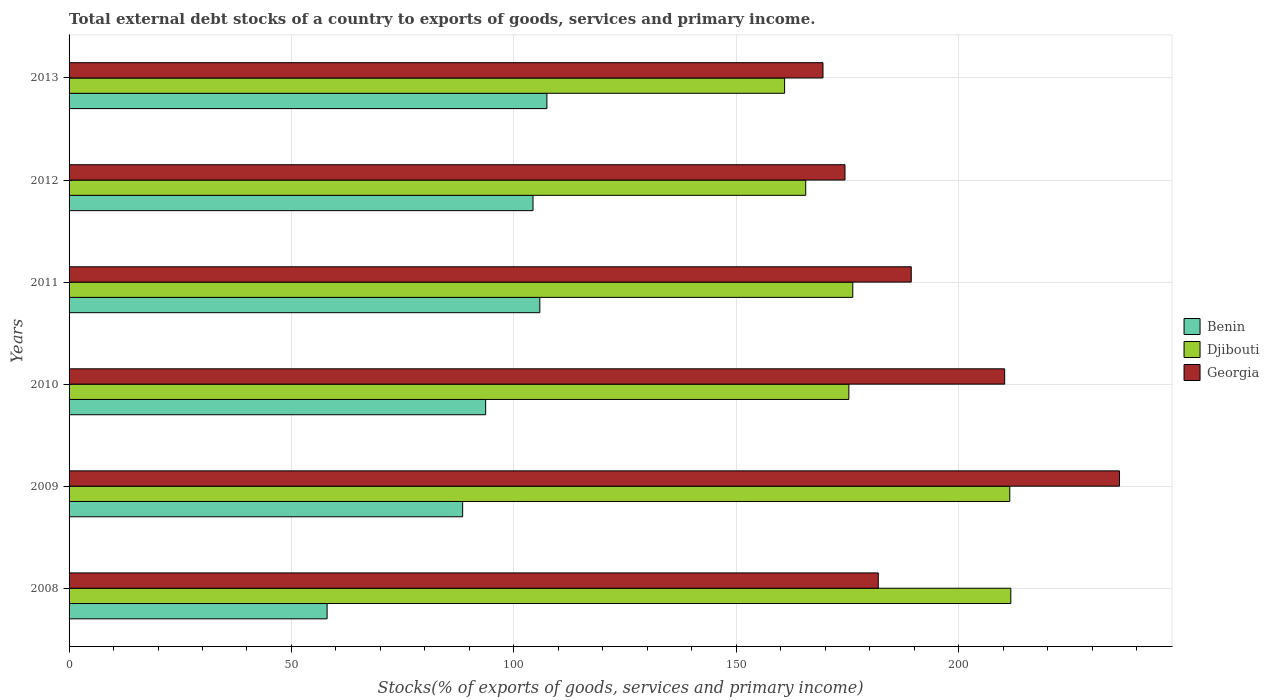Are the number of bars per tick equal to the number of legend labels?
Offer a terse response. Yes. Are the number of bars on each tick of the Y-axis equal?
Offer a very short reply. Yes. How many bars are there on the 3rd tick from the bottom?
Make the answer very short. 3. What is the label of the 6th group of bars from the top?
Your answer should be very brief. 2008. What is the total debt stocks in Benin in 2008?
Your response must be concise. 58.01. Across all years, what is the maximum total debt stocks in Benin?
Offer a very short reply. 107.43. Across all years, what is the minimum total debt stocks in Djibouti?
Keep it short and to the point. 160.87. In which year was the total debt stocks in Benin maximum?
Offer a terse response. 2013. In which year was the total debt stocks in Georgia minimum?
Provide a succinct answer. 2013. What is the total total debt stocks in Djibouti in the graph?
Offer a terse response. 1101.24. What is the difference between the total debt stocks in Benin in 2011 and that in 2012?
Your answer should be compact. 1.53. What is the difference between the total debt stocks in Georgia in 2010 and the total debt stocks in Benin in 2009?
Provide a short and direct response. 121.87. What is the average total debt stocks in Georgia per year?
Your answer should be very brief. 193.62. In the year 2008, what is the difference between the total debt stocks in Georgia and total debt stocks in Djibouti?
Offer a terse response. -29.8. In how many years, is the total debt stocks in Benin greater than 90 %?
Offer a very short reply. 4. What is the ratio of the total debt stocks in Djibouti in 2008 to that in 2011?
Offer a terse response. 1.2. Is the difference between the total debt stocks in Georgia in 2010 and 2011 greater than the difference between the total debt stocks in Djibouti in 2010 and 2011?
Offer a terse response. Yes. What is the difference between the highest and the second highest total debt stocks in Benin?
Keep it short and to the point. 1.59. What is the difference between the highest and the lowest total debt stocks in Djibouti?
Provide a short and direct response. 50.86. What does the 1st bar from the top in 2008 represents?
Your answer should be compact. Georgia. What does the 3rd bar from the bottom in 2009 represents?
Provide a succinct answer. Georgia. Is it the case that in every year, the sum of the total debt stocks in Benin and total debt stocks in Djibouti is greater than the total debt stocks in Georgia?
Keep it short and to the point. Yes. Are all the bars in the graph horizontal?
Keep it short and to the point. Yes. How many years are there in the graph?
Your answer should be compact. 6. Are the values on the major ticks of X-axis written in scientific E-notation?
Your answer should be compact. No. Does the graph contain any zero values?
Offer a very short reply. No. Does the graph contain grids?
Keep it short and to the point. Yes. What is the title of the graph?
Provide a short and direct response. Total external debt stocks of a country to exports of goods, services and primary income. Does "Bahamas" appear as one of the legend labels in the graph?
Your response must be concise. No. What is the label or title of the X-axis?
Give a very brief answer. Stocks(% of exports of goods, services and primary income). What is the label or title of the Y-axis?
Offer a terse response. Years. What is the Stocks(% of exports of goods, services and primary income) in Benin in 2008?
Provide a succinct answer. 58.01. What is the Stocks(% of exports of goods, services and primary income) of Djibouti in 2008?
Give a very brief answer. 211.73. What is the Stocks(% of exports of goods, services and primary income) in Georgia in 2008?
Your answer should be very brief. 181.93. What is the Stocks(% of exports of goods, services and primary income) in Benin in 2009?
Offer a terse response. 88.48. What is the Stocks(% of exports of goods, services and primary income) in Djibouti in 2009?
Your answer should be compact. 211.5. What is the Stocks(% of exports of goods, services and primary income) in Georgia in 2009?
Offer a terse response. 236.17. What is the Stocks(% of exports of goods, services and primary income) of Benin in 2010?
Offer a terse response. 93.66. What is the Stocks(% of exports of goods, services and primary income) of Djibouti in 2010?
Give a very brief answer. 175.32. What is the Stocks(% of exports of goods, services and primary income) of Georgia in 2010?
Keep it short and to the point. 210.35. What is the Stocks(% of exports of goods, services and primary income) in Benin in 2011?
Ensure brevity in your answer.  105.84. What is the Stocks(% of exports of goods, services and primary income) of Djibouti in 2011?
Provide a succinct answer. 176.2. What is the Stocks(% of exports of goods, services and primary income) in Georgia in 2011?
Make the answer very short. 189.34. What is the Stocks(% of exports of goods, services and primary income) of Benin in 2012?
Make the answer very short. 104.31. What is the Stocks(% of exports of goods, services and primary income) of Djibouti in 2012?
Keep it short and to the point. 165.62. What is the Stocks(% of exports of goods, services and primary income) of Georgia in 2012?
Your answer should be compact. 174.45. What is the Stocks(% of exports of goods, services and primary income) in Benin in 2013?
Your response must be concise. 107.43. What is the Stocks(% of exports of goods, services and primary income) in Djibouti in 2013?
Ensure brevity in your answer.  160.87. What is the Stocks(% of exports of goods, services and primary income) of Georgia in 2013?
Offer a terse response. 169.5. Across all years, what is the maximum Stocks(% of exports of goods, services and primary income) of Benin?
Make the answer very short. 107.43. Across all years, what is the maximum Stocks(% of exports of goods, services and primary income) of Djibouti?
Make the answer very short. 211.73. Across all years, what is the maximum Stocks(% of exports of goods, services and primary income) of Georgia?
Your answer should be compact. 236.17. Across all years, what is the minimum Stocks(% of exports of goods, services and primary income) of Benin?
Make the answer very short. 58.01. Across all years, what is the minimum Stocks(% of exports of goods, services and primary income) of Djibouti?
Give a very brief answer. 160.87. Across all years, what is the minimum Stocks(% of exports of goods, services and primary income) of Georgia?
Give a very brief answer. 169.5. What is the total Stocks(% of exports of goods, services and primary income) in Benin in the graph?
Give a very brief answer. 557.74. What is the total Stocks(% of exports of goods, services and primary income) in Djibouti in the graph?
Your answer should be compact. 1101.24. What is the total Stocks(% of exports of goods, services and primary income) in Georgia in the graph?
Ensure brevity in your answer.  1161.74. What is the difference between the Stocks(% of exports of goods, services and primary income) of Benin in 2008 and that in 2009?
Make the answer very short. -30.47. What is the difference between the Stocks(% of exports of goods, services and primary income) of Djibouti in 2008 and that in 2009?
Your answer should be compact. 0.23. What is the difference between the Stocks(% of exports of goods, services and primary income) of Georgia in 2008 and that in 2009?
Offer a terse response. -54.24. What is the difference between the Stocks(% of exports of goods, services and primary income) of Benin in 2008 and that in 2010?
Your response must be concise. -35.65. What is the difference between the Stocks(% of exports of goods, services and primary income) in Djibouti in 2008 and that in 2010?
Offer a very short reply. 36.41. What is the difference between the Stocks(% of exports of goods, services and primary income) in Georgia in 2008 and that in 2010?
Offer a terse response. -28.42. What is the difference between the Stocks(% of exports of goods, services and primary income) in Benin in 2008 and that in 2011?
Provide a succinct answer. -47.82. What is the difference between the Stocks(% of exports of goods, services and primary income) of Djibouti in 2008 and that in 2011?
Offer a very short reply. 35.53. What is the difference between the Stocks(% of exports of goods, services and primary income) in Georgia in 2008 and that in 2011?
Offer a very short reply. -7.41. What is the difference between the Stocks(% of exports of goods, services and primary income) in Benin in 2008 and that in 2012?
Your answer should be very brief. -46.29. What is the difference between the Stocks(% of exports of goods, services and primary income) in Djibouti in 2008 and that in 2012?
Provide a succinct answer. 46.11. What is the difference between the Stocks(% of exports of goods, services and primary income) in Georgia in 2008 and that in 2012?
Make the answer very short. 7.48. What is the difference between the Stocks(% of exports of goods, services and primary income) of Benin in 2008 and that in 2013?
Ensure brevity in your answer.  -49.42. What is the difference between the Stocks(% of exports of goods, services and primary income) in Djibouti in 2008 and that in 2013?
Your response must be concise. 50.86. What is the difference between the Stocks(% of exports of goods, services and primary income) of Georgia in 2008 and that in 2013?
Ensure brevity in your answer.  12.43. What is the difference between the Stocks(% of exports of goods, services and primary income) of Benin in 2009 and that in 2010?
Offer a terse response. -5.18. What is the difference between the Stocks(% of exports of goods, services and primary income) in Djibouti in 2009 and that in 2010?
Ensure brevity in your answer.  36.18. What is the difference between the Stocks(% of exports of goods, services and primary income) of Georgia in 2009 and that in 2010?
Make the answer very short. 25.82. What is the difference between the Stocks(% of exports of goods, services and primary income) of Benin in 2009 and that in 2011?
Offer a very short reply. -17.35. What is the difference between the Stocks(% of exports of goods, services and primary income) of Djibouti in 2009 and that in 2011?
Offer a terse response. 35.3. What is the difference between the Stocks(% of exports of goods, services and primary income) of Georgia in 2009 and that in 2011?
Offer a terse response. 46.83. What is the difference between the Stocks(% of exports of goods, services and primary income) in Benin in 2009 and that in 2012?
Keep it short and to the point. -15.82. What is the difference between the Stocks(% of exports of goods, services and primary income) in Djibouti in 2009 and that in 2012?
Your answer should be very brief. 45.88. What is the difference between the Stocks(% of exports of goods, services and primary income) in Georgia in 2009 and that in 2012?
Give a very brief answer. 61.72. What is the difference between the Stocks(% of exports of goods, services and primary income) in Benin in 2009 and that in 2013?
Offer a terse response. -18.95. What is the difference between the Stocks(% of exports of goods, services and primary income) of Djibouti in 2009 and that in 2013?
Provide a short and direct response. 50.62. What is the difference between the Stocks(% of exports of goods, services and primary income) in Georgia in 2009 and that in 2013?
Give a very brief answer. 66.67. What is the difference between the Stocks(% of exports of goods, services and primary income) in Benin in 2010 and that in 2011?
Provide a short and direct response. -12.18. What is the difference between the Stocks(% of exports of goods, services and primary income) of Djibouti in 2010 and that in 2011?
Your answer should be compact. -0.88. What is the difference between the Stocks(% of exports of goods, services and primary income) of Georgia in 2010 and that in 2011?
Your response must be concise. 21.01. What is the difference between the Stocks(% of exports of goods, services and primary income) of Benin in 2010 and that in 2012?
Ensure brevity in your answer.  -10.65. What is the difference between the Stocks(% of exports of goods, services and primary income) of Djibouti in 2010 and that in 2012?
Provide a succinct answer. 9.7. What is the difference between the Stocks(% of exports of goods, services and primary income) in Georgia in 2010 and that in 2012?
Your answer should be compact. 35.9. What is the difference between the Stocks(% of exports of goods, services and primary income) of Benin in 2010 and that in 2013?
Offer a terse response. -13.77. What is the difference between the Stocks(% of exports of goods, services and primary income) in Djibouti in 2010 and that in 2013?
Make the answer very short. 14.44. What is the difference between the Stocks(% of exports of goods, services and primary income) in Georgia in 2010 and that in 2013?
Your answer should be compact. 40.85. What is the difference between the Stocks(% of exports of goods, services and primary income) in Benin in 2011 and that in 2012?
Give a very brief answer. 1.53. What is the difference between the Stocks(% of exports of goods, services and primary income) of Djibouti in 2011 and that in 2012?
Give a very brief answer. 10.58. What is the difference between the Stocks(% of exports of goods, services and primary income) in Georgia in 2011 and that in 2012?
Your answer should be compact. 14.89. What is the difference between the Stocks(% of exports of goods, services and primary income) of Benin in 2011 and that in 2013?
Your answer should be compact. -1.59. What is the difference between the Stocks(% of exports of goods, services and primary income) of Djibouti in 2011 and that in 2013?
Provide a short and direct response. 15.32. What is the difference between the Stocks(% of exports of goods, services and primary income) of Georgia in 2011 and that in 2013?
Provide a short and direct response. 19.84. What is the difference between the Stocks(% of exports of goods, services and primary income) in Benin in 2012 and that in 2013?
Your answer should be compact. -3.12. What is the difference between the Stocks(% of exports of goods, services and primary income) in Djibouti in 2012 and that in 2013?
Your answer should be compact. 4.75. What is the difference between the Stocks(% of exports of goods, services and primary income) of Georgia in 2012 and that in 2013?
Keep it short and to the point. 4.95. What is the difference between the Stocks(% of exports of goods, services and primary income) of Benin in 2008 and the Stocks(% of exports of goods, services and primary income) of Djibouti in 2009?
Ensure brevity in your answer.  -153.48. What is the difference between the Stocks(% of exports of goods, services and primary income) in Benin in 2008 and the Stocks(% of exports of goods, services and primary income) in Georgia in 2009?
Your response must be concise. -178.15. What is the difference between the Stocks(% of exports of goods, services and primary income) of Djibouti in 2008 and the Stocks(% of exports of goods, services and primary income) of Georgia in 2009?
Ensure brevity in your answer.  -24.44. What is the difference between the Stocks(% of exports of goods, services and primary income) of Benin in 2008 and the Stocks(% of exports of goods, services and primary income) of Djibouti in 2010?
Your response must be concise. -117.3. What is the difference between the Stocks(% of exports of goods, services and primary income) in Benin in 2008 and the Stocks(% of exports of goods, services and primary income) in Georgia in 2010?
Your response must be concise. -152.33. What is the difference between the Stocks(% of exports of goods, services and primary income) of Djibouti in 2008 and the Stocks(% of exports of goods, services and primary income) of Georgia in 2010?
Offer a very short reply. 1.38. What is the difference between the Stocks(% of exports of goods, services and primary income) in Benin in 2008 and the Stocks(% of exports of goods, services and primary income) in Djibouti in 2011?
Make the answer very short. -118.18. What is the difference between the Stocks(% of exports of goods, services and primary income) of Benin in 2008 and the Stocks(% of exports of goods, services and primary income) of Georgia in 2011?
Make the answer very short. -131.33. What is the difference between the Stocks(% of exports of goods, services and primary income) of Djibouti in 2008 and the Stocks(% of exports of goods, services and primary income) of Georgia in 2011?
Provide a short and direct response. 22.39. What is the difference between the Stocks(% of exports of goods, services and primary income) in Benin in 2008 and the Stocks(% of exports of goods, services and primary income) in Djibouti in 2012?
Make the answer very short. -107.6. What is the difference between the Stocks(% of exports of goods, services and primary income) of Benin in 2008 and the Stocks(% of exports of goods, services and primary income) of Georgia in 2012?
Your response must be concise. -116.44. What is the difference between the Stocks(% of exports of goods, services and primary income) of Djibouti in 2008 and the Stocks(% of exports of goods, services and primary income) of Georgia in 2012?
Your response must be concise. 37.28. What is the difference between the Stocks(% of exports of goods, services and primary income) of Benin in 2008 and the Stocks(% of exports of goods, services and primary income) of Djibouti in 2013?
Your response must be concise. -102.86. What is the difference between the Stocks(% of exports of goods, services and primary income) in Benin in 2008 and the Stocks(% of exports of goods, services and primary income) in Georgia in 2013?
Offer a very short reply. -111.49. What is the difference between the Stocks(% of exports of goods, services and primary income) in Djibouti in 2008 and the Stocks(% of exports of goods, services and primary income) in Georgia in 2013?
Make the answer very short. 42.23. What is the difference between the Stocks(% of exports of goods, services and primary income) of Benin in 2009 and the Stocks(% of exports of goods, services and primary income) of Djibouti in 2010?
Make the answer very short. -86.83. What is the difference between the Stocks(% of exports of goods, services and primary income) of Benin in 2009 and the Stocks(% of exports of goods, services and primary income) of Georgia in 2010?
Offer a terse response. -121.87. What is the difference between the Stocks(% of exports of goods, services and primary income) in Djibouti in 2009 and the Stocks(% of exports of goods, services and primary income) in Georgia in 2010?
Make the answer very short. 1.15. What is the difference between the Stocks(% of exports of goods, services and primary income) of Benin in 2009 and the Stocks(% of exports of goods, services and primary income) of Djibouti in 2011?
Give a very brief answer. -87.71. What is the difference between the Stocks(% of exports of goods, services and primary income) of Benin in 2009 and the Stocks(% of exports of goods, services and primary income) of Georgia in 2011?
Your answer should be compact. -100.86. What is the difference between the Stocks(% of exports of goods, services and primary income) of Djibouti in 2009 and the Stocks(% of exports of goods, services and primary income) of Georgia in 2011?
Ensure brevity in your answer.  22.15. What is the difference between the Stocks(% of exports of goods, services and primary income) of Benin in 2009 and the Stocks(% of exports of goods, services and primary income) of Djibouti in 2012?
Provide a succinct answer. -77.14. What is the difference between the Stocks(% of exports of goods, services and primary income) of Benin in 2009 and the Stocks(% of exports of goods, services and primary income) of Georgia in 2012?
Your response must be concise. -85.97. What is the difference between the Stocks(% of exports of goods, services and primary income) in Djibouti in 2009 and the Stocks(% of exports of goods, services and primary income) in Georgia in 2012?
Provide a short and direct response. 37.05. What is the difference between the Stocks(% of exports of goods, services and primary income) of Benin in 2009 and the Stocks(% of exports of goods, services and primary income) of Djibouti in 2013?
Give a very brief answer. -72.39. What is the difference between the Stocks(% of exports of goods, services and primary income) in Benin in 2009 and the Stocks(% of exports of goods, services and primary income) in Georgia in 2013?
Your response must be concise. -81.02. What is the difference between the Stocks(% of exports of goods, services and primary income) of Djibouti in 2009 and the Stocks(% of exports of goods, services and primary income) of Georgia in 2013?
Offer a terse response. 42. What is the difference between the Stocks(% of exports of goods, services and primary income) of Benin in 2010 and the Stocks(% of exports of goods, services and primary income) of Djibouti in 2011?
Your response must be concise. -82.54. What is the difference between the Stocks(% of exports of goods, services and primary income) of Benin in 2010 and the Stocks(% of exports of goods, services and primary income) of Georgia in 2011?
Ensure brevity in your answer.  -95.68. What is the difference between the Stocks(% of exports of goods, services and primary income) of Djibouti in 2010 and the Stocks(% of exports of goods, services and primary income) of Georgia in 2011?
Make the answer very short. -14.02. What is the difference between the Stocks(% of exports of goods, services and primary income) in Benin in 2010 and the Stocks(% of exports of goods, services and primary income) in Djibouti in 2012?
Make the answer very short. -71.96. What is the difference between the Stocks(% of exports of goods, services and primary income) in Benin in 2010 and the Stocks(% of exports of goods, services and primary income) in Georgia in 2012?
Your response must be concise. -80.79. What is the difference between the Stocks(% of exports of goods, services and primary income) in Djibouti in 2010 and the Stocks(% of exports of goods, services and primary income) in Georgia in 2012?
Offer a very short reply. 0.87. What is the difference between the Stocks(% of exports of goods, services and primary income) of Benin in 2010 and the Stocks(% of exports of goods, services and primary income) of Djibouti in 2013?
Your answer should be compact. -67.21. What is the difference between the Stocks(% of exports of goods, services and primary income) in Benin in 2010 and the Stocks(% of exports of goods, services and primary income) in Georgia in 2013?
Offer a very short reply. -75.84. What is the difference between the Stocks(% of exports of goods, services and primary income) of Djibouti in 2010 and the Stocks(% of exports of goods, services and primary income) of Georgia in 2013?
Give a very brief answer. 5.82. What is the difference between the Stocks(% of exports of goods, services and primary income) in Benin in 2011 and the Stocks(% of exports of goods, services and primary income) in Djibouti in 2012?
Keep it short and to the point. -59.78. What is the difference between the Stocks(% of exports of goods, services and primary income) of Benin in 2011 and the Stocks(% of exports of goods, services and primary income) of Georgia in 2012?
Ensure brevity in your answer.  -68.61. What is the difference between the Stocks(% of exports of goods, services and primary income) of Djibouti in 2011 and the Stocks(% of exports of goods, services and primary income) of Georgia in 2012?
Offer a terse response. 1.75. What is the difference between the Stocks(% of exports of goods, services and primary income) of Benin in 2011 and the Stocks(% of exports of goods, services and primary income) of Djibouti in 2013?
Give a very brief answer. -55.04. What is the difference between the Stocks(% of exports of goods, services and primary income) of Benin in 2011 and the Stocks(% of exports of goods, services and primary income) of Georgia in 2013?
Your answer should be compact. -63.66. What is the difference between the Stocks(% of exports of goods, services and primary income) of Djibouti in 2011 and the Stocks(% of exports of goods, services and primary income) of Georgia in 2013?
Keep it short and to the point. 6.7. What is the difference between the Stocks(% of exports of goods, services and primary income) of Benin in 2012 and the Stocks(% of exports of goods, services and primary income) of Djibouti in 2013?
Offer a very short reply. -56.57. What is the difference between the Stocks(% of exports of goods, services and primary income) in Benin in 2012 and the Stocks(% of exports of goods, services and primary income) in Georgia in 2013?
Your answer should be compact. -65.19. What is the difference between the Stocks(% of exports of goods, services and primary income) in Djibouti in 2012 and the Stocks(% of exports of goods, services and primary income) in Georgia in 2013?
Your answer should be very brief. -3.88. What is the average Stocks(% of exports of goods, services and primary income) in Benin per year?
Give a very brief answer. 92.96. What is the average Stocks(% of exports of goods, services and primary income) of Djibouti per year?
Your answer should be compact. 183.54. What is the average Stocks(% of exports of goods, services and primary income) of Georgia per year?
Your answer should be compact. 193.62. In the year 2008, what is the difference between the Stocks(% of exports of goods, services and primary income) of Benin and Stocks(% of exports of goods, services and primary income) of Djibouti?
Offer a very short reply. -153.72. In the year 2008, what is the difference between the Stocks(% of exports of goods, services and primary income) in Benin and Stocks(% of exports of goods, services and primary income) in Georgia?
Make the answer very short. -123.91. In the year 2008, what is the difference between the Stocks(% of exports of goods, services and primary income) of Djibouti and Stocks(% of exports of goods, services and primary income) of Georgia?
Keep it short and to the point. 29.8. In the year 2009, what is the difference between the Stocks(% of exports of goods, services and primary income) of Benin and Stocks(% of exports of goods, services and primary income) of Djibouti?
Keep it short and to the point. -123.01. In the year 2009, what is the difference between the Stocks(% of exports of goods, services and primary income) of Benin and Stocks(% of exports of goods, services and primary income) of Georgia?
Your response must be concise. -147.69. In the year 2009, what is the difference between the Stocks(% of exports of goods, services and primary income) of Djibouti and Stocks(% of exports of goods, services and primary income) of Georgia?
Make the answer very short. -24.67. In the year 2010, what is the difference between the Stocks(% of exports of goods, services and primary income) of Benin and Stocks(% of exports of goods, services and primary income) of Djibouti?
Provide a short and direct response. -81.66. In the year 2010, what is the difference between the Stocks(% of exports of goods, services and primary income) in Benin and Stocks(% of exports of goods, services and primary income) in Georgia?
Ensure brevity in your answer.  -116.69. In the year 2010, what is the difference between the Stocks(% of exports of goods, services and primary income) in Djibouti and Stocks(% of exports of goods, services and primary income) in Georgia?
Make the answer very short. -35.03. In the year 2011, what is the difference between the Stocks(% of exports of goods, services and primary income) of Benin and Stocks(% of exports of goods, services and primary income) of Djibouti?
Make the answer very short. -70.36. In the year 2011, what is the difference between the Stocks(% of exports of goods, services and primary income) of Benin and Stocks(% of exports of goods, services and primary income) of Georgia?
Keep it short and to the point. -83.5. In the year 2011, what is the difference between the Stocks(% of exports of goods, services and primary income) in Djibouti and Stocks(% of exports of goods, services and primary income) in Georgia?
Offer a very short reply. -13.14. In the year 2012, what is the difference between the Stocks(% of exports of goods, services and primary income) of Benin and Stocks(% of exports of goods, services and primary income) of Djibouti?
Provide a succinct answer. -61.31. In the year 2012, what is the difference between the Stocks(% of exports of goods, services and primary income) of Benin and Stocks(% of exports of goods, services and primary income) of Georgia?
Your answer should be compact. -70.14. In the year 2012, what is the difference between the Stocks(% of exports of goods, services and primary income) of Djibouti and Stocks(% of exports of goods, services and primary income) of Georgia?
Provide a succinct answer. -8.83. In the year 2013, what is the difference between the Stocks(% of exports of goods, services and primary income) in Benin and Stocks(% of exports of goods, services and primary income) in Djibouti?
Make the answer very short. -53.44. In the year 2013, what is the difference between the Stocks(% of exports of goods, services and primary income) of Benin and Stocks(% of exports of goods, services and primary income) of Georgia?
Your response must be concise. -62.07. In the year 2013, what is the difference between the Stocks(% of exports of goods, services and primary income) in Djibouti and Stocks(% of exports of goods, services and primary income) in Georgia?
Provide a succinct answer. -8.63. What is the ratio of the Stocks(% of exports of goods, services and primary income) in Benin in 2008 to that in 2009?
Offer a terse response. 0.66. What is the ratio of the Stocks(% of exports of goods, services and primary income) of Georgia in 2008 to that in 2009?
Give a very brief answer. 0.77. What is the ratio of the Stocks(% of exports of goods, services and primary income) in Benin in 2008 to that in 2010?
Your answer should be compact. 0.62. What is the ratio of the Stocks(% of exports of goods, services and primary income) in Djibouti in 2008 to that in 2010?
Keep it short and to the point. 1.21. What is the ratio of the Stocks(% of exports of goods, services and primary income) in Georgia in 2008 to that in 2010?
Ensure brevity in your answer.  0.86. What is the ratio of the Stocks(% of exports of goods, services and primary income) in Benin in 2008 to that in 2011?
Keep it short and to the point. 0.55. What is the ratio of the Stocks(% of exports of goods, services and primary income) of Djibouti in 2008 to that in 2011?
Give a very brief answer. 1.2. What is the ratio of the Stocks(% of exports of goods, services and primary income) of Georgia in 2008 to that in 2011?
Your answer should be compact. 0.96. What is the ratio of the Stocks(% of exports of goods, services and primary income) of Benin in 2008 to that in 2012?
Make the answer very short. 0.56. What is the ratio of the Stocks(% of exports of goods, services and primary income) of Djibouti in 2008 to that in 2012?
Offer a very short reply. 1.28. What is the ratio of the Stocks(% of exports of goods, services and primary income) of Georgia in 2008 to that in 2012?
Your response must be concise. 1.04. What is the ratio of the Stocks(% of exports of goods, services and primary income) in Benin in 2008 to that in 2013?
Keep it short and to the point. 0.54. What is the ratio of the Stocks(% of exports of goods, services and primary income) of Djibouti in 2008 to that in 2013?
Provide a succinct answer. 1.32. What is the ratio of the Stocks(% of exports of goods, services and primary income) in Georgia in 2008 to that in 2013?
Make the answer very short. 1.07. What is the ratio of the Stocks(% of exports of goods, services and primary income) in Benin in 2009 to that in 2010?
Ensure brevity in your answer.  0.94. What is the ratio of the Stocks(% of exports of goods, services and primary income) in Djibouti in 2009 to that in 2010?
Provide a succinct answer. 1.21. What is the ratio of the Stocks(% of exports of goods, services and primary income) of Georgia in 2009 to that in 2010?
Ensure brevity in your answer.  1.12. What is the ratio of the Stocks(% of exports of goods, services and primary income) of Benin in 2009 to that in 2011?
Ensure brevity in your answer.  0.84. What is the ratio of the Stocks(% of exports of goods, services and primary income) in Djibouti in 2009 to that in 2011?
Your answer should be very brief. 1.2. What is the ratio of the Stocks(% of exports of goods, services and primary income) in Georgia in 2009 to that in 2011?
Your response must be concise. 1.25. What is the ratio of the Stocks(% of exports of goods, services and primary income) of Benin in 2009 to that in 2012?
Your answer should be very brief. 0.85. What is the ratio of the Stocks(% of exports of goods, services and primary income) in Djibouti in 2009 to that in 2012?
Ensure brevity in your answer.  1.28. What is the ratio of the Stocks(% of exports of goods, services and primary income) in Georgia in 2009 to that in 2012?
Your answer should be very brief. 1.35. What is the ratio of the Stocks(% of exports of goods, services and primary income) of Benin in 2009 to that in 2013?
Your answer should be compact. 0.82. What is the ratio of the Stocks(% of exports of goods, services and primary income) of Djibouti in 2009 to that in 2013?
Ensure brevity in your answer.  1.31. What is the ratio of the Stocks(% of exports of goods, services and primary income) of Georgia in 2009 to that in 2013?
Give a very brief answer. 1.39. What is the ratio of the Stocks(% of exports of goods, services and primary income) in Benin in 2010 to that in 2011?
Your answer should be very brief. 0.89. What is the ratio of the Stocks(% of exports of goods, services and primary income) of Georgia in 2010 to that in 2011?
Keep it short and to the point. 1.11. What is the ratio of the Stocks(% of exports of goods, services and primary income) of Benin in 2010 to that in 2012?
Give a very brief answer. 0.9. What is the ratio of the Stocks(% of exports of goods, services and primary income) of Djibouti in 2010 to that in 2012?
Your answer should be very brief. 1.06. What is the ratio of the Stocks(% of exports of goods, services and primary income) in Georgia in 2010 to that in 2012?
Offer a terse response. 1.21. What is the ratio of the Stocks(% of exports of goods, services and primary income) of Benin in 2010 to that in 2013?
Keep it short and to the point. 0.87. What is the ratio of the Stocks(% of exports of goods, services and primary income) of Djibouti in 2010 to that in 2013?
Provide a short and direct response. 1.09. What is the ratio of the Stocks(% of exports of goods, services and primary income) in Georgia in 2010 to that in 2013?
Provide a succinct answer. 1.24. What is the ratio of the Stocks(% of exports of goods, services and primary income) in Benin in 2011 to that in 2012?
Offer a terse response. 1.01. What is the ratio of the Stocks(% of exports of goods, services and primary income) in Djibouti in 2011 to that in 2012?
Your answer should be very brief. 1.06. What is the ratio of the Stocks(% of exports of goods, services and primary income) of Georgia in 2011 to that in 2012?
Your answer should be very brief. 1.09. What is the ratio of the Stocks(% of exports of goods, services and primary income) of Benin in 2011 to that in 2013?
Give a very brief answer. 0.99. What is the ratio of the Stocks(% of exports of goods, services and primary income) of Djibouti in 2011 to that in 2013?
Ensure brevity in your answer.  1.1. What is the ratio of the Stocks(% of exports of goods, services and primary income) in Georgia in 2011 to that in 2013?
Keep it short and to the point. 1.12. What is the ratio of the Stocks(% of exports of goods, services and primary income) in Benin in 2012 to that in 2013?
Give a very brief answer. 0.97. What is the ratio of the Stocks(% of exports of goods, services and primary income) in Djibouti in 2012 to that in 2013?
Ensure brevity in your answer.  1.03. What is the ratio of the Stocks(% of exports of goods, services and primary income) of Georgia in 2012 to that in 2013?
Give a very brief answer. 1.03. What is the difference between the highest and the second highest Stocks(% of exports of goods, services and primary income) of Benin?
Provide a succinct answer. 1.59. What is the difference between the highest and the second highest Stocks(% of exports of goods, services and primary income) in Djibouti?
Your response must be concise. 0.23. What is the difference between the highest and the second highest Stocks(% of exports of goods, services and primary income) in Georgia?
Provide a short and direct response. 25.82. What is the difference between the highest and the lowest Stocks(% of exports of goods, services and primary income) of Benin?
Provide a short and direct response. 49.42. What is the difference between the highest and the lowest Stocks(% of exports of goods, services and primary income) in Djibouti?
Keep it short and to the point. 50.86. What is the difference between the highest and the lowest Stocks(% of exports of goods, services and primary income) in Georgia?
Make the answer very short. 66.67. 